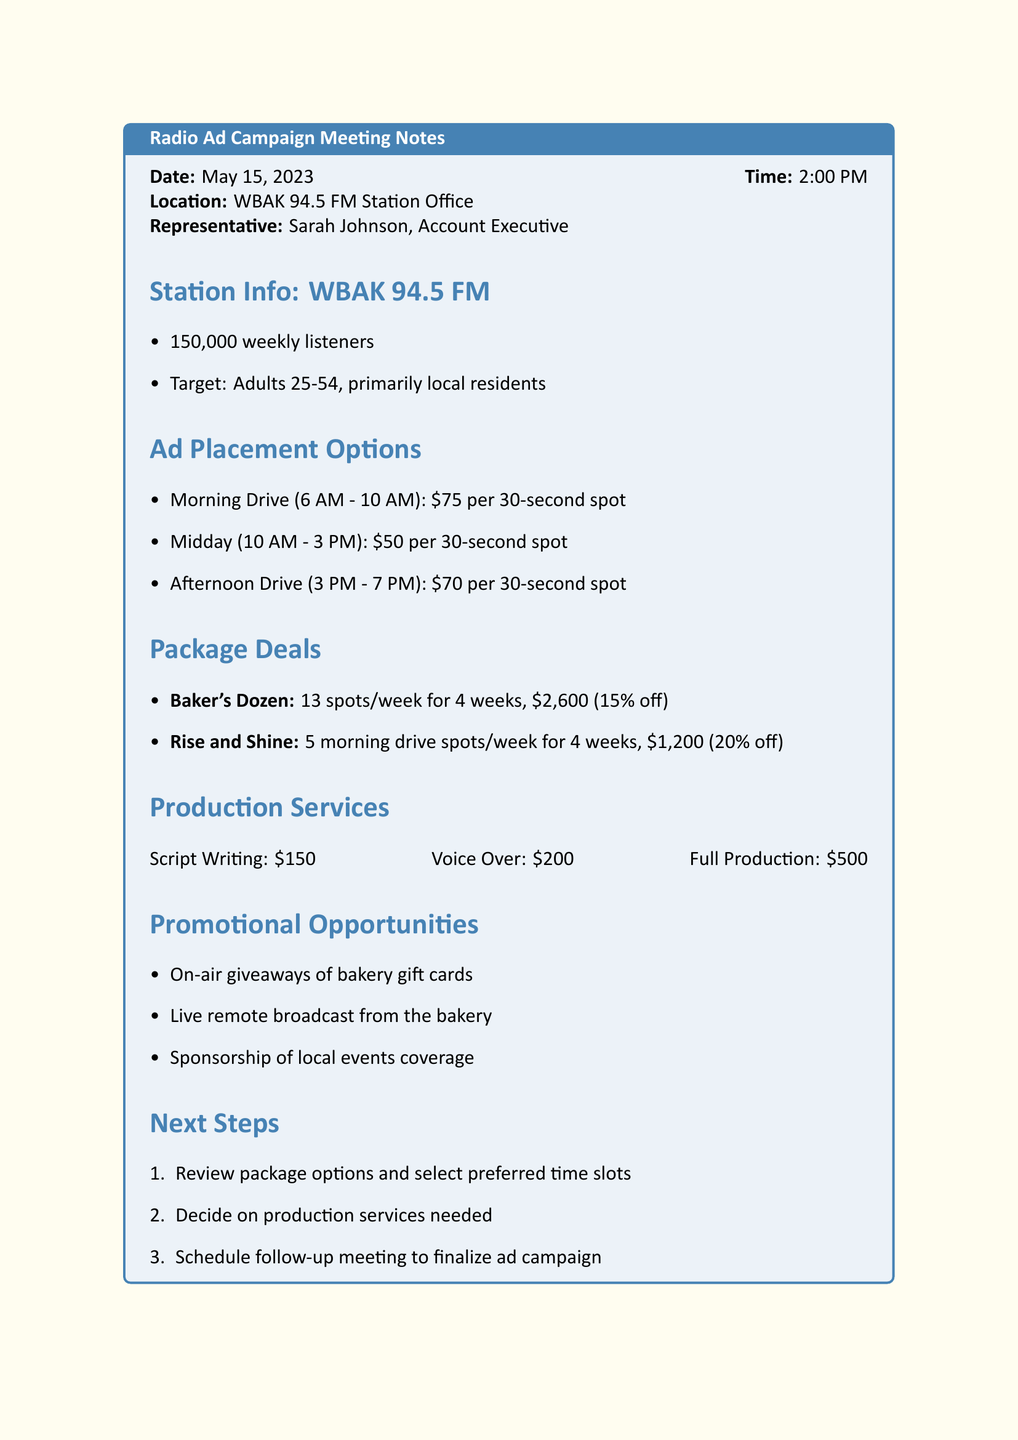What is the date of the meeting? The date of the meeting is specifically mentioned in the document as May 15, 2023.
Answer: May 15, 2023 Who is the representative from the radio station? The document names Sarah Johnson as the Account Executive representing WBAK 94.5 FM.
Answer: Sarah Johnson How many weekly listeners does WBAK 94.5 FM have? The document states that WBAK 94.5 FM has 150,000 weekly listeners.
Answer: 150,000 What is the cost of a 30-second ad spot during midday? The cost for a 30-second spot during midday is detailed in the document, specifically listed as $50.
Answer: $50 What is the name of the package deal that offers 13 spots per week? The document clearly states that the package deal offering 13 spots is called Baker's Dozen.
Answer: Baker's Dozen What percentage savings does the "Rise and Shine" package provide? The savings for the "Rise and Shine" package are explicitly mentioned in the document as 20% off regular rates.
Answer: 20% What is included in the full production service? The document lists the full production service as costing $500.
Answer: $500 What promotional opportunity involves live broadcasting? The document mentions a promotional opportunity for a live remote broadcast from the bakery.
Answer: Live remote broadcast from the bakery What is the next step listed for the campaign? The next step includes reviewing package options and selecting preferred time slots, which is highlighted in the document.
Answer: Review package options and select preferred time slots 